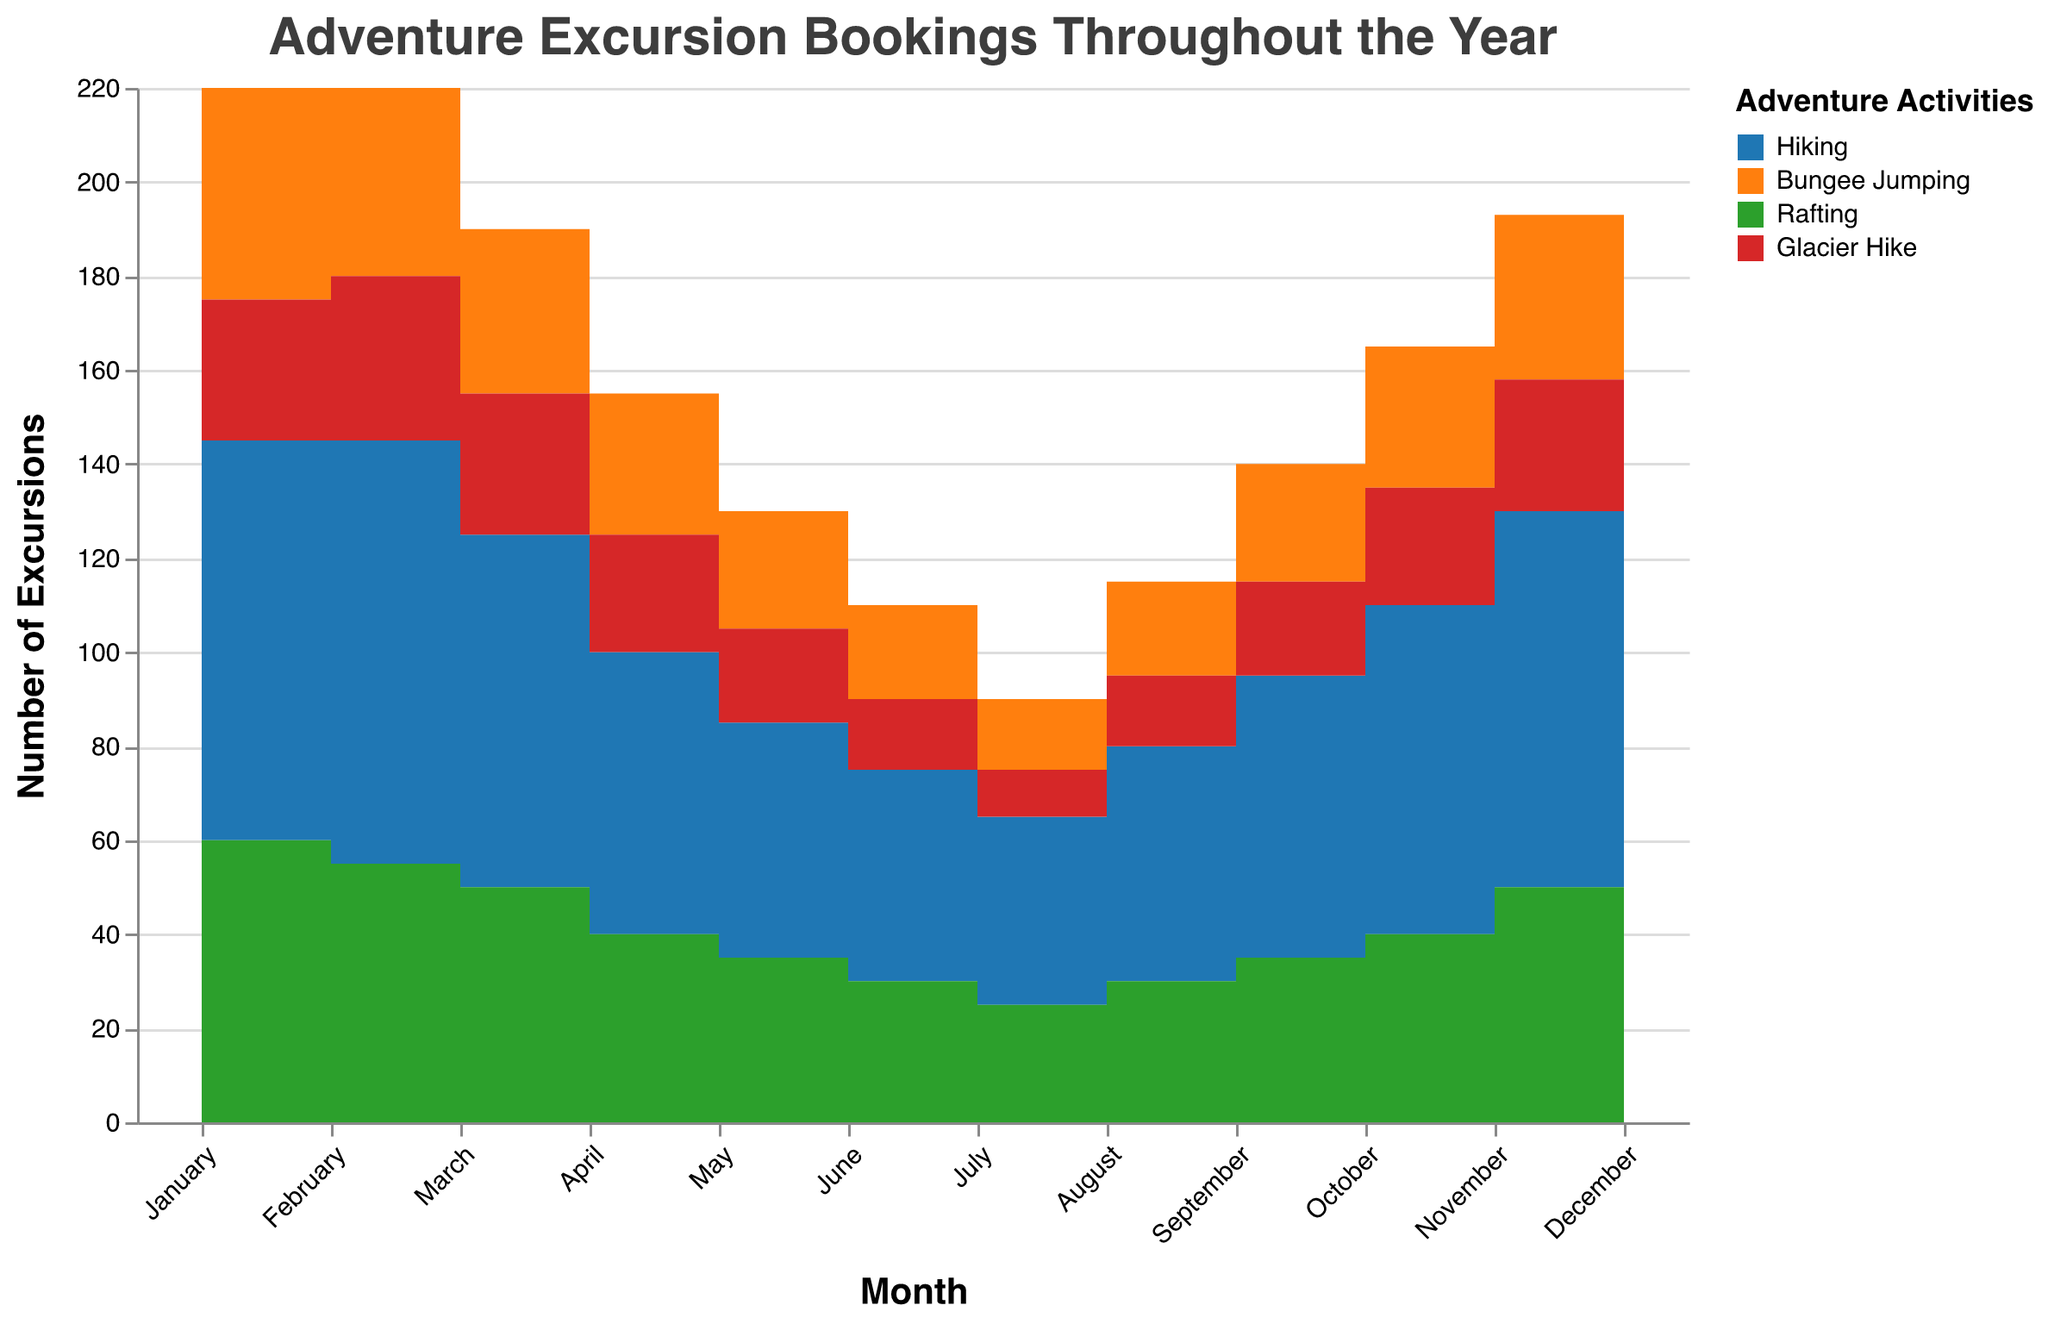What is the title of the chart? The title is displayed at the top of the chart, typically in a larger font size for emphasis. It reads "Adventure Excursion Bookings Throughout the Year".
Answer: Adventure Excursion Bookings Throughout the Year Which activity has the highest number of bookings in January? In January, 'Hiking' has the highest number of bookings compared to 'Bungee Jumping', 'Rafting', and 'Glacier Hike'. This is indicated by the highest step in the area plot for Hiking.
Answer: Hiking How do the bookings for 'Hiking' change from June to July? To determine this, we look at the step changes in the area plot for 'Hiking' between June and July. 'Hiking' drops from 45 bookings in June to 40 in July, indicating a decline.
Answer: Decline by 5 What is the average number of 'Bungee Jumping' bookings from March to May? Find the booking numbers for 'Bungee Jumping' in March, April, and May (35, 30, 25 respectively), sum them up, and divide by the number of months: (35+30+25)/3 = 90/3 = 30.
Answer: 30 In which month are 'Rafting' bookings the lowest, and what is the number? The lowest step for 'Rafting' occurs in July, showing the lowest number of bookings which is 25.
Answer: July, 25 bookings Which month shows the highest combined bookings for all activities? Look for the month with the highest combined stacked area segments. December shows the highest combined value. Summing the values: 90 (Hiking) + 40 (Bungee Jumping) + 55 (Rafting) + 30 (Glacier Hike) = 215.
Answer: December, 215 bookings Compare 'Glacier Hike' bookings between February and November. Which month had higher bookings? Check the steps for 'Glacier Hike'. February shows 35 bookings while November shows 28. February is higher.
Answer: February What is the total number of 'Hiking' bookings in the first half of the year (January to June)? Sum the 'Hiking' bookings from January to June: 85 + 90 + 75 + 60 + 50 + 45 = 405.
Answer: 405 How does 'Bungee Jumping' bookings trend from July to December? Observe the sequential steps in the 'Bungee Jumping' area from July to December. It increases from 15 (July) to 40 (December).
Answer: Increasing What significant trend do you see for 'Glacier Hike' throughout the year? Look at the steps of the 'Glacier Hike' area plot. It starts at 30 in January, fluctuates slightly but generally decreases to 10 in July, then gradually increases back to 30 by December.
Answer: Decreases then increases 